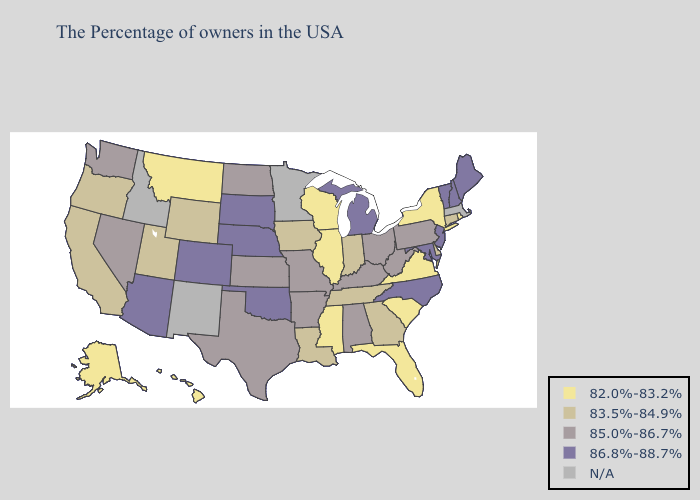Name the states that have a value in the range N/A?
Be succinct. Massachusetts, Minnesota, New Mexico, Idaho. What is the lowest value in the South?
Give a very brief answer. 82.0%-83.2%. Does Delaware have the highest value in the South?
Quick response, please. No. Among the states that border Iowa , does Nebraska have the highest value?
Concise answer only. Yes. Does Delaware have the highest value in the South?
Be succinct. No. Which states hav the highest value in the West?
Keep it brief. Colorado, Arizona. Which states have the lowest value in the USA?
Be succinct. Rhode Island, New York, Virginia, South Carolina, Florida, Wisconsin, Illinois, Mississippi, Montana, Alaska, Hawaii. Does the map have missing data?
Keep it brief. Yes. Name the states that have a value in the range 82.0%-83.2%?
Write a very short answer. Rhode Island, New York, Virginia, South Carolina, Florida, Wisconsin, Illinois, Mississippi, Montana, Alaska, Hawaii. What is the value of Nevada?
Quick response, please. 85.0%-86.7%. What is the value of Virginia?
Be succinct. 82.0%-83.2%. Among the states that border Vermont , does New Hampshire have the highest value?
Quick response, please. Yes. What is the value of Oregon?
Be succinct. 83.5%-84.9%. What is the highest value in the USA?
Quick response, please. 86.8%-88.7%. What is the value of Maryland?
Quick response, please. 86.8%-88.7%. 